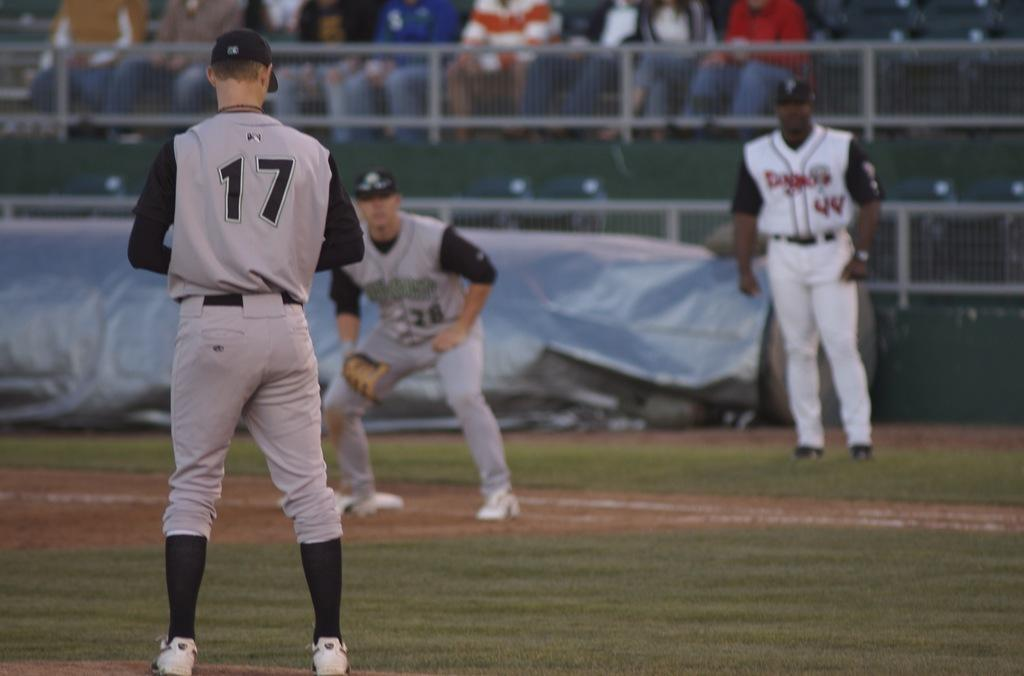<image>
Relay a brief, clear account of the picture shown. One of the players on the field wears the number 17 on their back. 